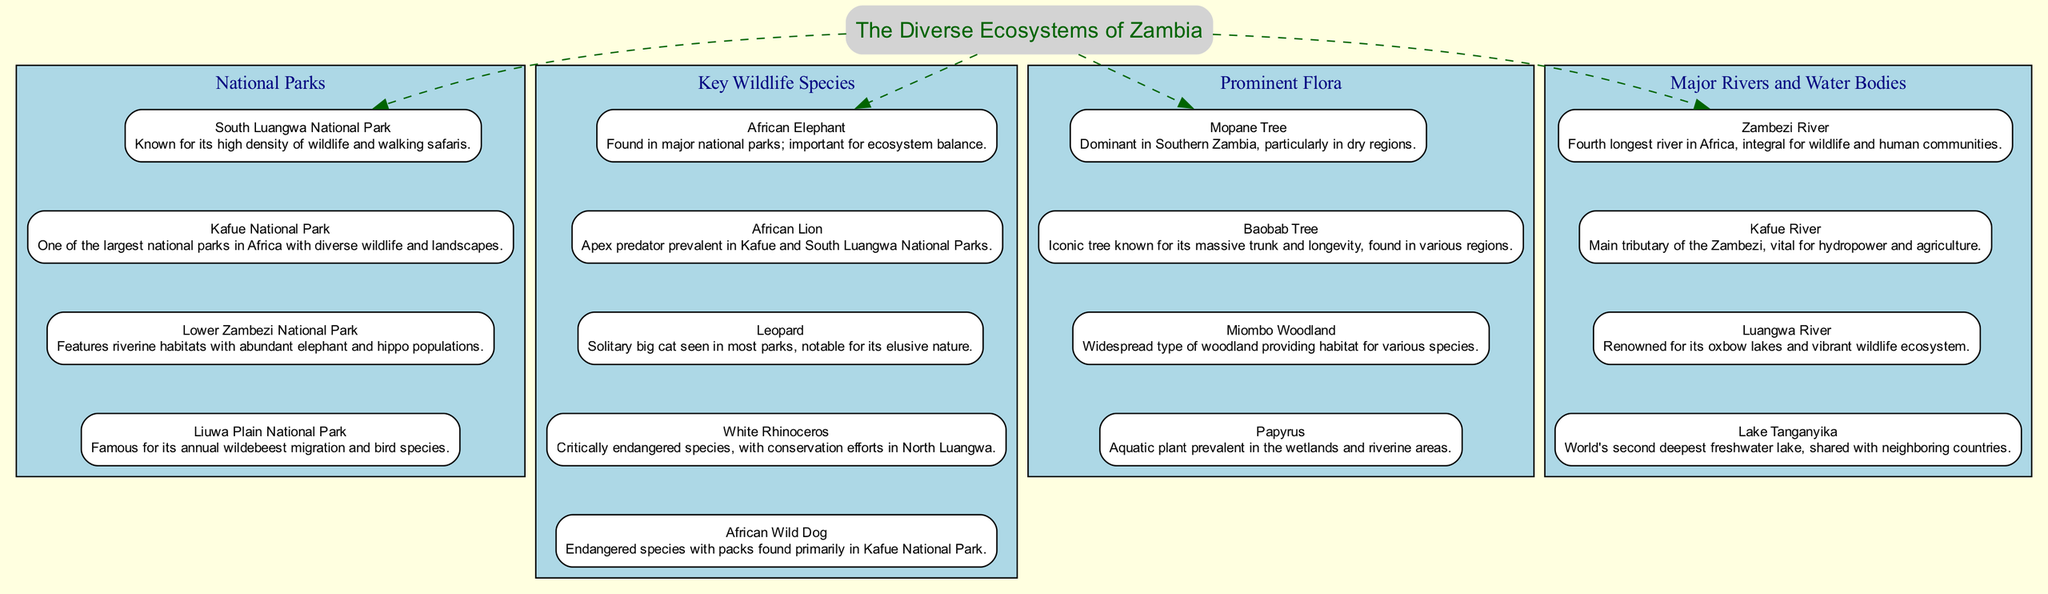What is the title of the diagram? The title node clearly states "The Diverse Ecosystems of Zambia" which represents the overall theme of the diagram.
Answer: The Diverse Ecosystems of Zambia How many national parks are listed? By counting the individual park items under the "National Parks" section, we find there are four national parks mentioned.
Answer: 4 Which national park is known for walking safaris? The item describing "South Luangwa National Park" mentions its high density of wildlife and walking safaris.
Answer: South Luangwa National Park What prominent fauna is critically endangered? In the "Key Wildlife Species" section, "White Rhinoceros" is labeled as a critically endangered species.
Answer: White Rhinoceros Which river is integral for wildlife and human communities? The description for "Zambezi River" states it is the fourth longest river in Africa and is critical for wildlife and human settlements.
Answer: Zambezi River Which tree is dominant in Southern Zambia? The "Mopane Tree" is specifically mentioned as being dominant in Southern Zambia, particularly in dry regions.
Answer: Mopane Tree What is a notable feature of Liuwa Plain National Park? The item for "Liuwa Plain National Park" states it is famous for its annual wildebeest migration and bird species.
Answer: Annual wildebeest migration Which species is noted for its elusive nature? The description of the "Leopard" in the "Key Wildlife Species" section highlights its solitary and elusive characteristics.
Answer: Leopard How many key wildlife species are listed? By counting the entries under the "Key Wildlife Species" section, there are five species listed in total.
Answer: 5 In which national park is the African Wild Dog primarily found? The "Key Wildlife Species" section indicates that African Wild Dogs are primarily found in Kafue National Park.
Answer: Kafue National Park 